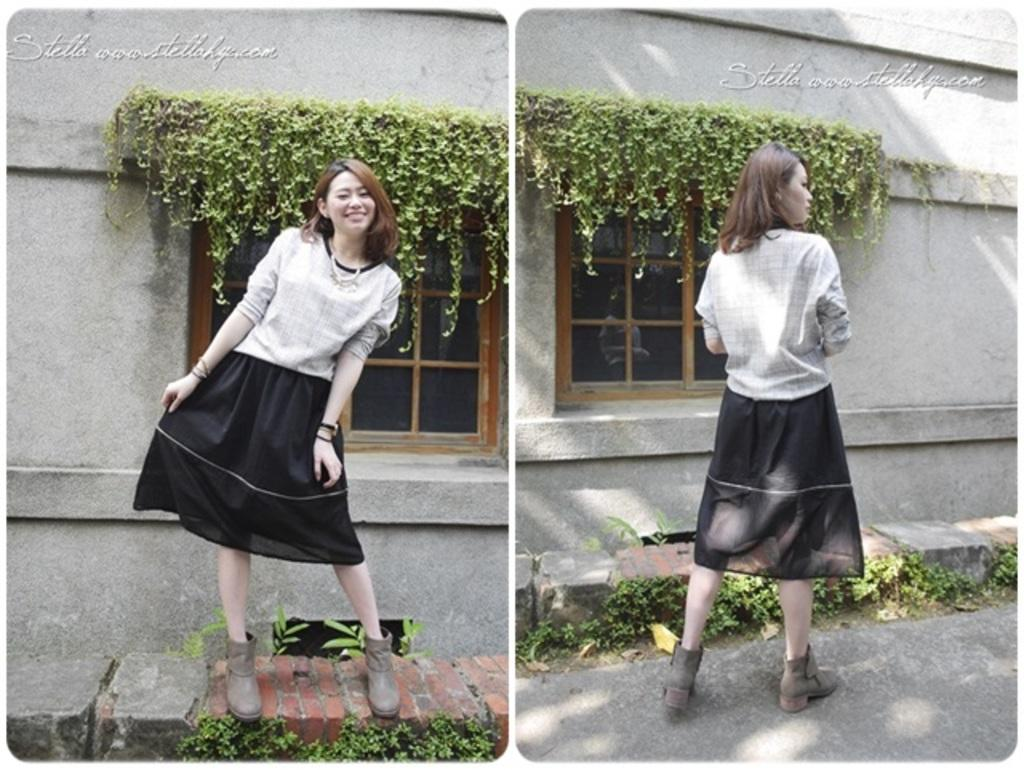What type of visual composition is present in the image? The image contains a collage of pictures. Can you describe any subjects or objects that are present in the pictures? There is a lady, windows, plants, walls, and rocks visible in at least one of the pictures. Are there any written words or phrases in the image? Yes, there is text on at least one of the pictures. What type of nut can be seen being leveled in the image? There is no nut or leveling activity present in the image. How does the digestion process appear in the image? There is no depiction of a digestion process in the image. 